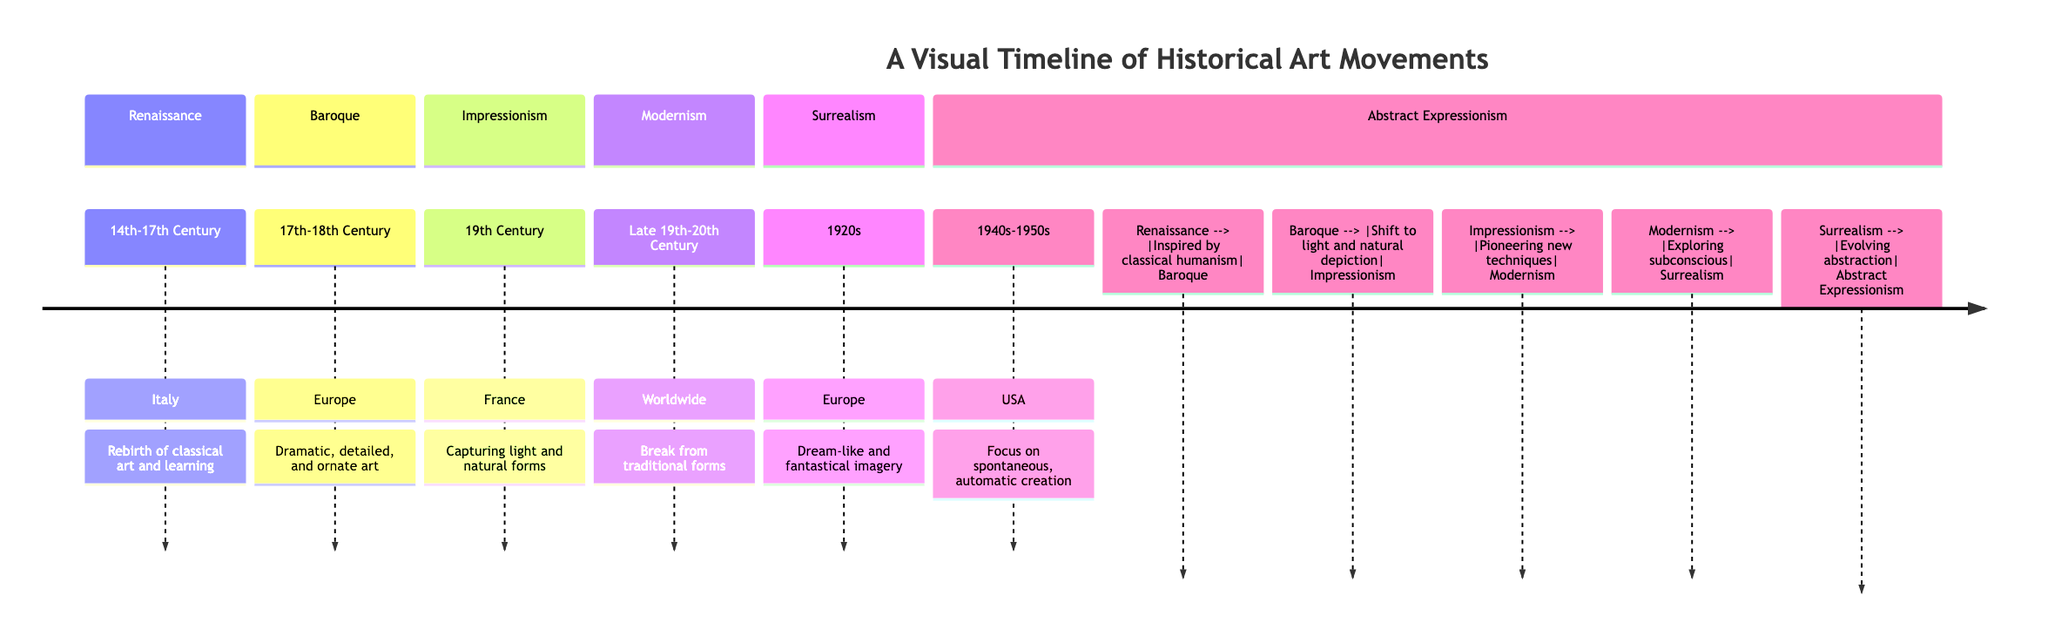What is the geographic origin of Baroque? The diagram indicates that Baroque has its geographic origin in Europe.
Answer: Europe How many art movements are represented in the diagram? By counting the distinct sections in the timeline, we find there are six art movements represented.
Answer: 6 What art movement followed Impressionism? According to the connections in the diagram, Modernism follows Impressionism.
Answer: Modernism What time period is associated with Abstract Expressionism? The diagram specifies that Abstract Expressionism is associated with the 1940s-1950s.
Answer: 1940s-1950s Which art movement is described as "Dream-like and fantastical imagery"? The description linked to Surrealism in the diagram states it represents dream-like and fantastical imagery.
Answer: Surrealism Which art movement inspired Baroque? The diagram explicitly shows that Baroque was inspired by the Renaissance movement.
Answer: Renaissance What key transition occurs from Surrealism to Abstract Expressionism? The connection indicates that Surrealism evolves into abstraction, leading to Abstract Expressionism.
Answer: Evolving abstraction What does Modernism explore according to the diagram? The diagram notes that Modernism explores the subconscious, which signifies it breaks from traditional forms.
Answer: Subconscious How does Impressionism relate to Baroque in the visual timeline? The diagram indicates that there is a shift to light and natural depiction from Baroque to Impressionism.
Answer: Shift to light and natural depiction 